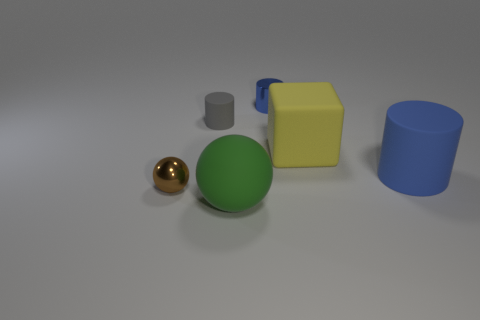Do the metal cylinder and the big cylinder have the same color?
Provide a succinct answer. Yes. How many rubber things are in front of the large blue rubber cylinder and left of the green rubber object?
Keep it short and to the point. 0. Do the rubber object that is in front of the large cylinder and the brown thing have the same shape?
Your answer should be compact. Yes. There is a gray object that is the same size as the shiny ball; what material is it?
Provide a succinct answer. Rubber. Is the number of gray cylinders to the left of the small rubber thing the same as the number of tiny rubber things that are in front of the brown object?
Give a very brief answer. Yes. How many small matte objects are on the right side of the matte object in front of the small thing that is left of the tiny gray cylinder?
Offer a terse response. 0. Do the small metallic cylinder and the rubber cylinder that is right of the green rubber thing have the same color?
Your answer should be compact. Yes. What is the size of the yellow cube that is made of the same material as the tiny gray object?
Provide a short and direct response. Large. Are there more large yellow objects that are in front of the metallic cylinder than small yellow objects?
Ensure brevity in your answer.  Yes. What material is the blue thing behind the gray rubber cylinder that is in front of the shiny object that is to the right of the tiny brown object made of?
Your answer should be compact. Metal. 